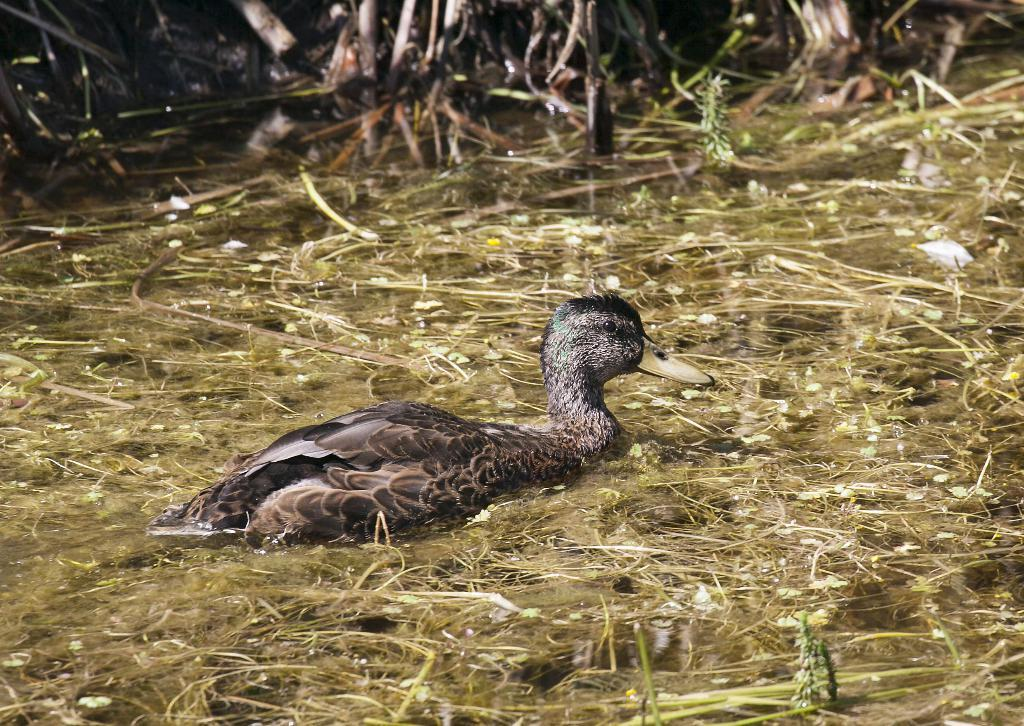What type of animal is present in the image? There is a duck in the image. What type of vegetation can be seen in the image? Creepers are visible in the image. Where are the creepers located? The creepers are on the water. What is the duck saying good-bye to in the image? There is no indication in the image that the duck is saying good-bye to anything or anyone. 